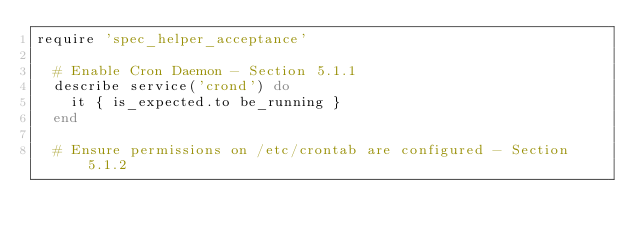<code> <loc_0><loc_0><loc_500><loc_500><_Ruby_>require 'spec_helper_acceptance'

  # Enable Cron Daemon - Section 5.1.1
  describe service('crond') do
    it { is_expected.to be_running }
  end

  # Ensure permissions on /etc/crontab are configured - Section 5.1.2</code> 